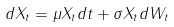Convert formula to latex. <formula><loc_0><loc_0><loc_500><loc_500>d X _ { t } = \mu X _ { t } d t + \sigma X _ { t } d W _ { t }</formula> 